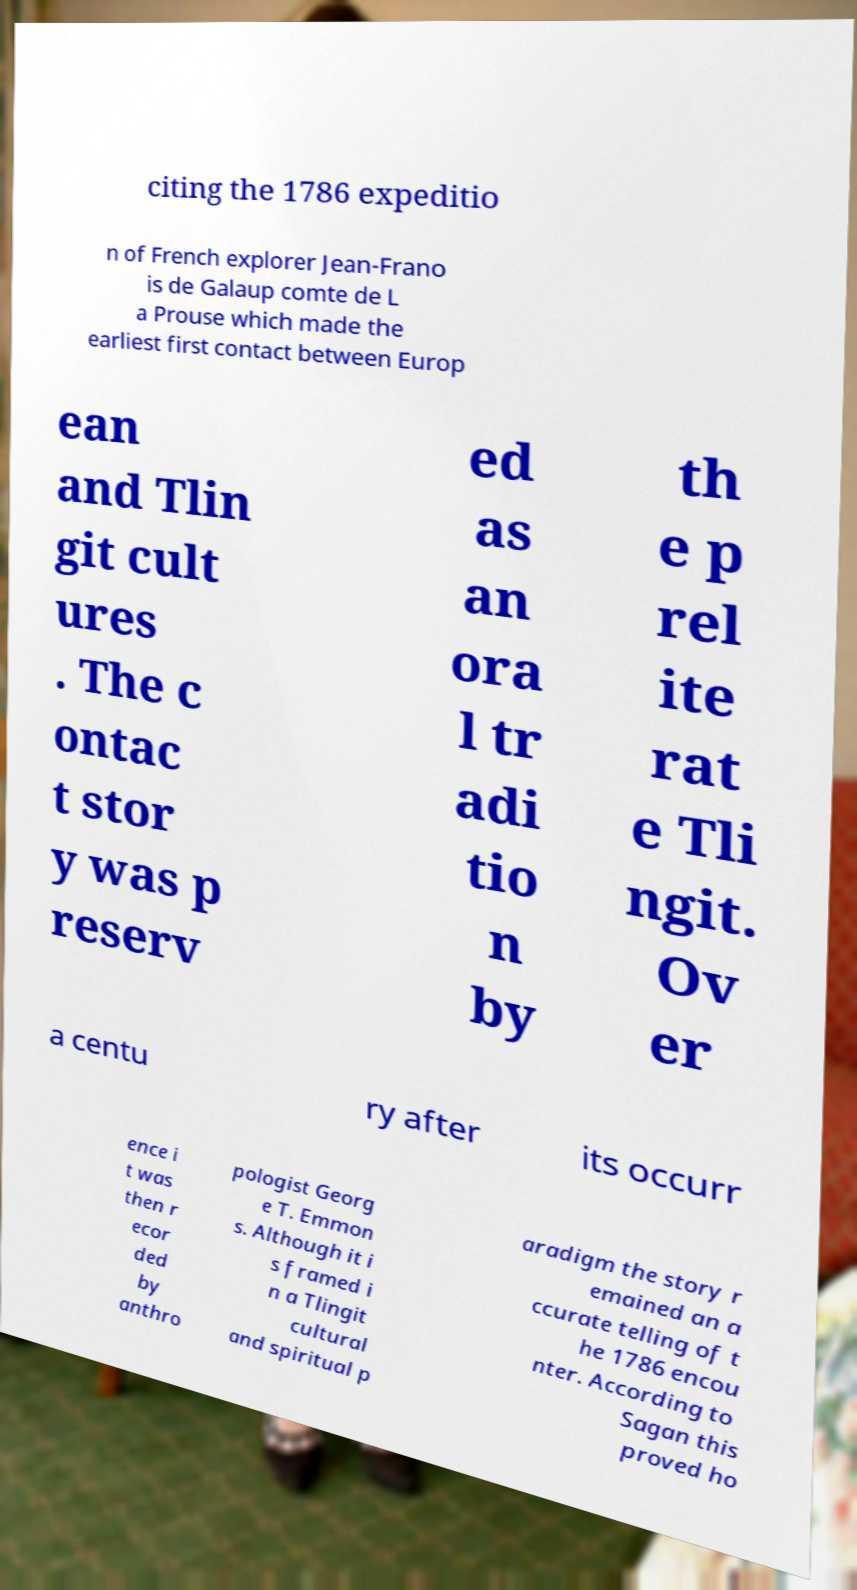For documentation purposes, I need the text within this image transcribed. Could you provide that? citing the 1786 expeditio n of French explorer Jean-Frano is de Galaup comte de L a Prouse which made the earliest first contact between Europ ean and Tlin git cult ures . The c ontac t stor y was p reserv ed as an ora l tr adi tio n by th e p rel ite rat e Tli ngit. Ov er a centu ry after its occurr ence i t was then r ecor ded by anthro pologist Georg e T. Emmon s. Although it i s framed i n a Tlingit cultural and spiritual p aradigm the story r emained an a ccurate telling of t he 1786 encou nter. According to Sagan this proved ho 